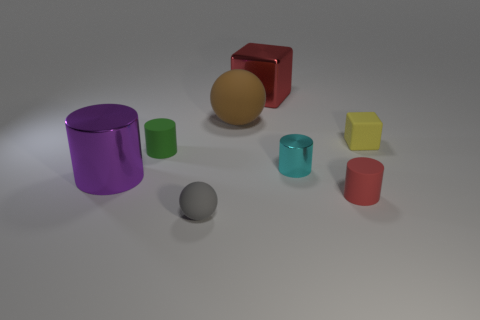Subtract 1 cylinders. How many cylinders are left? 3 Add 1 cubes. How many objects exist? 9 Subtract all balls. How many objects are left? 6 Subtract 1 brown spheres. How many objects are left? 7 Subtract all red rubber objects. Subtract all matte objects. How many objects are left? 2 Add 2 cyan metal things. How many cyan metal things are left? 3 Add 5 small yellow blocks. How many small yellow blocks exist? 6 